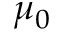<formula> <loc_0><loc_0><loc_500><loc_500>\mu _ { 0 }</formula> 